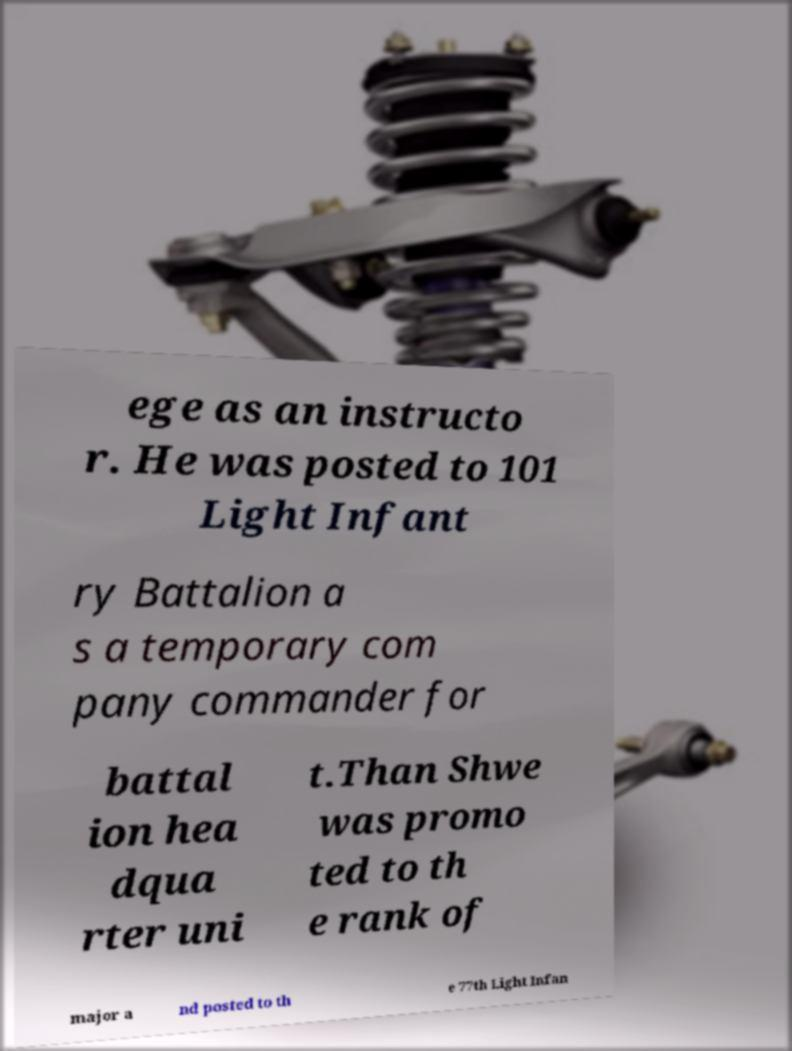Can you accurately transcribe the text from the provided image for me? ege as an instructo r. He was posted to 101 Light Infant ry Battalion a s a temporary com pany commander for battal ion hea dqua rter uni t.Than Shwe was promo ted to th e rank of major a nd posted to th e 77th Light Infan 